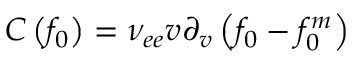Convert formula to latex. <formula><loc_0><loc_0><loc_500><loc_500>C \left ( { { f _ { 0 } } } \right ) = { \nu _ { e e } } v { \partial _ { v } } \left ( { { f _ { 0 } } - f _ { 0 } ^ { m } } \right )</formula> 